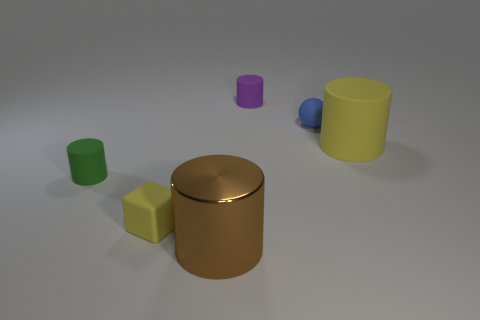Subtract all large brown cylinders. How many cylinders are left? 3 Add 3 tiny purple metallic objects. How many objects exist? 9 Subtract all brown cylinders. How many cylinders are left? 3 Subtract all cylinders. How many objects are left? 2 Add 4 small rubber cylinders. How many small rubber cylinders are left? 6 Add 4 large cylinders. How many large cylinders exist? 6 Subtract 0 green balls. How many objects are left? 6 Subtract all red cylinders. Subtract all yellow blocks. How many cylinders are left? 4 Subtract all yellow blocks. How many purple cylinders are left? 1 Subtract all purple cylinders. Subtract all blue objects. How many objects are left? 4 